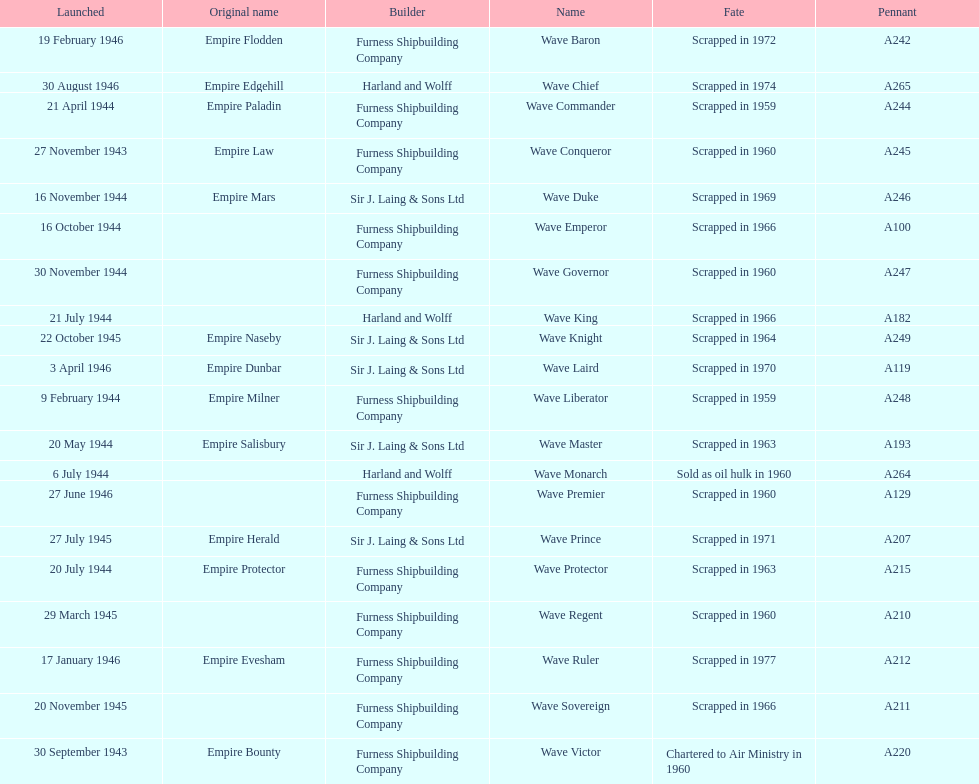Can you give me this table as a dict? {'header': ['Launched', 'Original name', 'Builder', 'Name', 'Fate', 'Pennant'], 'rows': [['19 February 1946', 'Empire Flodden', 'Furness Shipbuilding Company', 'Wave Baron', 'Scrapped in 1972', 'A242'], ['30 August 1946', 'Empire Edgehill', 'Harland and Wolff', 'Wave Chief', 'Scrapped in 1974', 'A265'], ['21 April 1944', 'Empire Paladin', 'Furness Shipbuilding Company', 'Wave Commander', 'Scrapped in 1959', 'A244'], ['27 November 1943', 'Empire Law', 'Furness Shipbuilding Company', 'Wave Conqueror', 'Scrapped in 1960', 'A245'], ['16 November 1944', 'Empire Mars', 'Sir J. Laing & Sons Ltd', 'Wave Duke', 'Scrapped in 1969', 'A246'], ['16 October 1944', '', 'Furness Shipbuilding Company', 'Wave Emperor', 'Scrapped in 1966', 'A100'], ['30 November 1944', '', 'Furness Shipbuilding Company', 'Wave Governor', 'Scrapped in 1960', 'A247'], ['21 July 1944', '', 'Harland and Wolff', 'Wave King', 'Scrapped in 1966', 'A182'], ['22 October 1945', 'Empire Naseby', 'Sir J. Laing & Sons Ltd', 'Wave Knight', 'Scrapped in 1964', 'A249'], ['3 April 1946', 'Empire Dunbar', 'Sir J. Laing & Sons Ltd', 'Wave Laird', 'Scrapped in 1970', 'A119'], ['9 February 1944', 'Empire Milner', 'Furness Shipbuilding Company', 'Wave Liberator', 'Scrapped in 1959', 'A248'], ['20 May 1944', 'Empire Salisbury', 'Sir J. Laing & Sons Ltd', 'Wave Master', 'Scrapped in 1963', 'A193'], ['6 July 1944', '', 'Harland and Wolff', 'Wave Monarch', 'Sold as oil hulk in 1960', 'A264'], ['27 June 1946', '', 'Furness Shipbuilding Company', 'Wave Premier', 'Scrapped in 1960', 'A129'], ['27 July 1945', 'Empire Herald', 'Sir J. Laing & Sons Ltd', 'Wave Prince', 'Scrapped in 1971', 'A207'], ['20 July 1944', 'Empire Protector', 'Furness Shipbuilding Company', 'Wave Protector', 'Scrapped in 1963', 'A215'], ['29 March 1945', '', 'Furness Shipbuilding Company', 'Wave Regent', 'Scrapped in 1960', 'A210'], ['17 January 1946', 'Empire Evesham', 'Furness Shipbuilding Company', 'Wave Ruler', 'Scrapped in 1977', 'A212'], ['20 November 1945', '', 'Furness Shipbuilding Company', 'Wave Sovereign', 'Scrapped in 1966', 'A211'], ['30 September 1943', 'Empire Bounty', 'Furness Shipbuilding Company', 'Wave Victor', 'Chartered to Air Ministry in 1960', 'A220']]} Name a builder with "and" in the name. Harland and Wolff. 